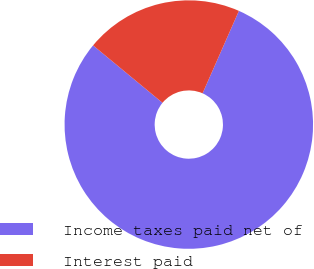Convert chart. <chart><loc_0><loc_0><loc_500><loc_500><pie_chart><fcel>Income taxes paid net of<fcel>Interest paid<nl><fcel>79.39%<fcel>20.61%<nl></chart> 